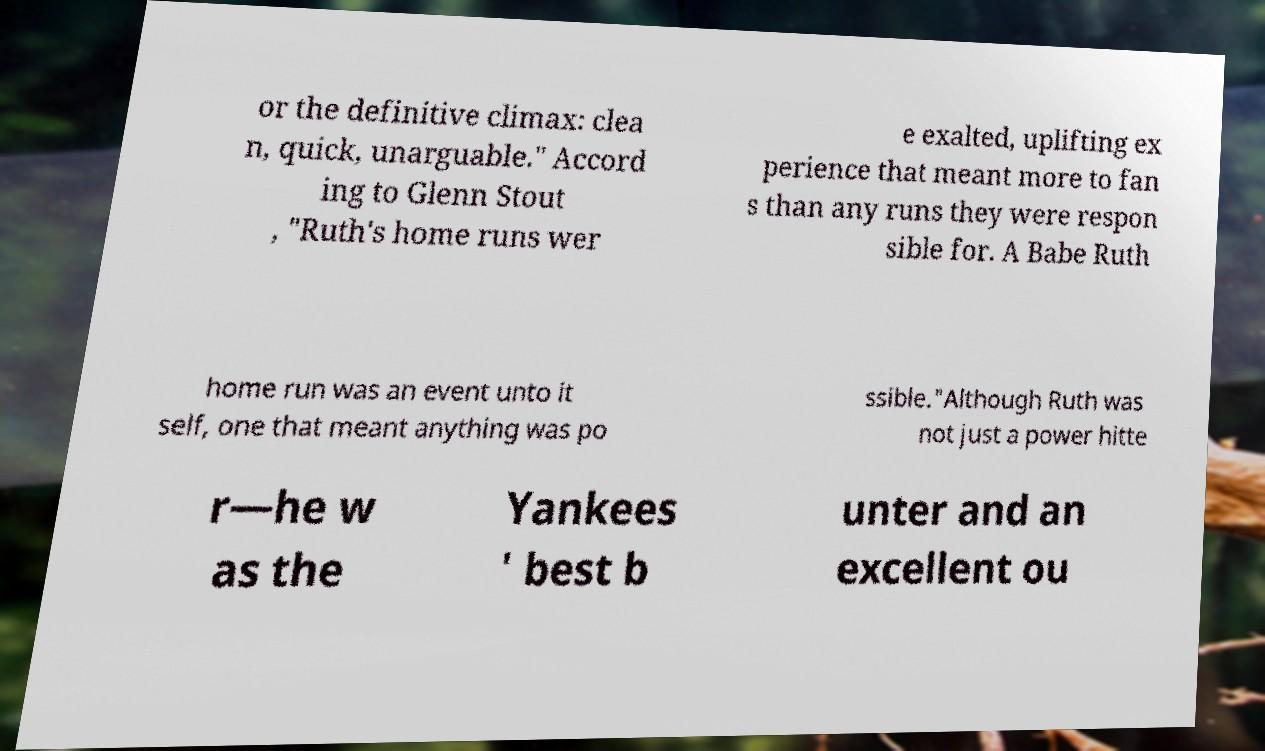Can you read and provide the text displayed in the image?This photo seems to have some interesting text. Can you extract and type it out for me? or the definitive climax: clea n, quick, unarguable." Accord ing to Glenn Stout , "Ruth's home runs wer e exalted, uplifting ex perience that meant more to fan s than any runs they were respon sible for. A Babe Ruth home run was an event unto it self, one that meant anything was po ssible."Although Ruth was not just a power hitte r—he w as the Yankees ' best b unter and an excellent ou 